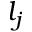Convert formula to latex. <formula><loc_0><loc_0><loc_500><loc_500>l _ { j }</formula> 